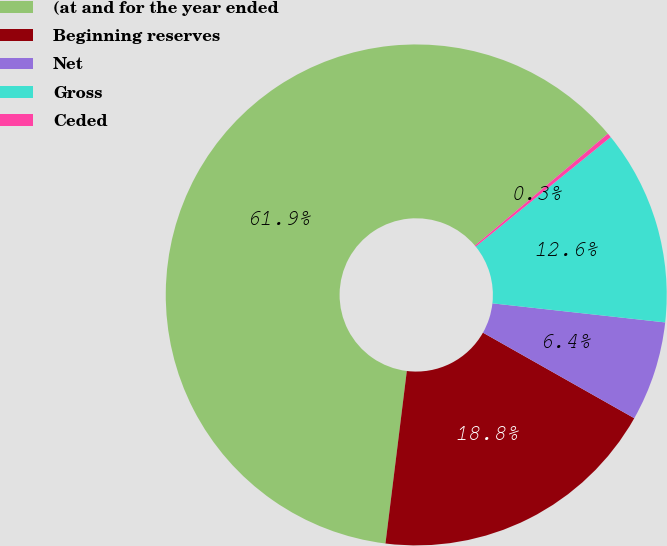Convert chart to OTSL. <chart><loc_0><loc_0><loc_500><loc_500><pie_chart><fcel>(at and for the year ended<fcel>Beginning reserves<fcel>Net<fcel>Gross<fcel>Ceded<nl><fcel>61.91%<fcel>18.77%<fcel>6.44%<fcel>12.6%<fcel>0.28%<nl></chart> 